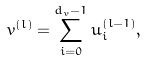<formula> <loc_0><loc_0><loc_500><loc_500>v ^ { ( l ) } = \sum _ { i = 0 } ^ { d _ { v } - 1 } u ^ { ( l - 1 ) } _ { i } ,</formula> 